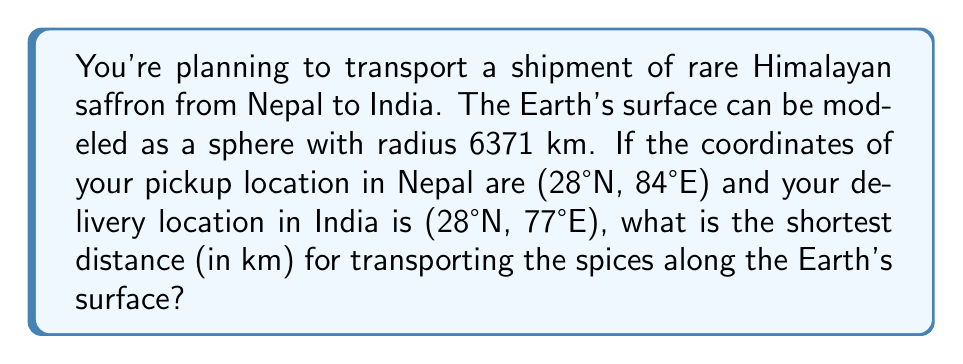Solve this math problem. To solve this problem, we need to use the concept of geodesics on a sphere, which are great circles. The shortest path between two points on a sphere is along the arc of a great circle passing through those points.

Step 1: Convert the coordinates to radians.
Both locations have the same latitude: 28°N = $\frac{28\pi}{180}$ radians
Nepal (longitude): 84°E = $\frac{84\pi}{180}$ radians
India (longitude): 77°E = $\frac{77\pi}{180}$ radians

Step 2: Calculate the central angle $\theta$ between the two points using the great circle distance formula:

$$\cos(\theta) = \sin(\phi_1)\sin(\phi_2) + \cos(\phi_1)\cos(\phi_2)\cos(|\lambda_2 - \lambda_1|)$$

Where $\phi_1 = \phi_2 = \frac{28\pi}{180}$ (latitude), and $|\lambda_2 - \lambda_1| = |\frac{77\pi}{180} - \frac{84\pi}{180}| = \frac{7\pi}{180}$ (difference in longitude)

$$\cos(\theta) = \sin(\frac{28\pi}{180})^2 + \cos(\frac{28\pi}{180})^2\cos(\frac{7\pi}{180})$$

Step 3: Calculate $\theta$ using the arccosine function:
$$\theta = \arccos(\cos(\theta))$$

Step 4: Calculate the distance $d$ along the great circle:
$$d = R\theta$$
Where $R = 6371$ km (Earth's radius)

Step 5: Perform the calculations:
$$\cos(\theta) \approx 0.9962$$
$$\theta \approx 0.0871 \text{ radians}$$
$$d = 6371 \times 0.0871 \approx 554.9 \text{ km}$$

Therefore, the shortest distance for transporting the spices is approximately 554.9 km.
Answer: 554.9 km 